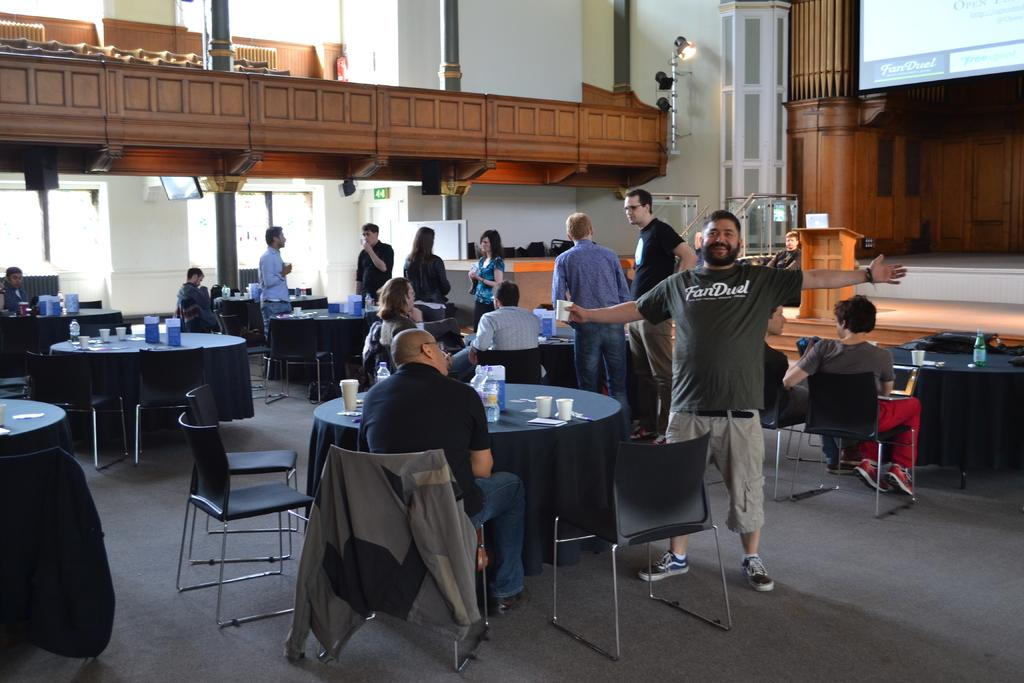What type of furniture is present in the image? There are tables and chairs in the image. What objects can be seen on the tables? Cups and bottles are on the tables in the image. Is there anyone visible in the image? Yes, a person is standing in the image. What is happening in the background of the image? People are talking to each other in the background of the image. What type of crate is being used to balance the cups on the table? There is no crate present in the image, and the cups are not balanced on anything. 